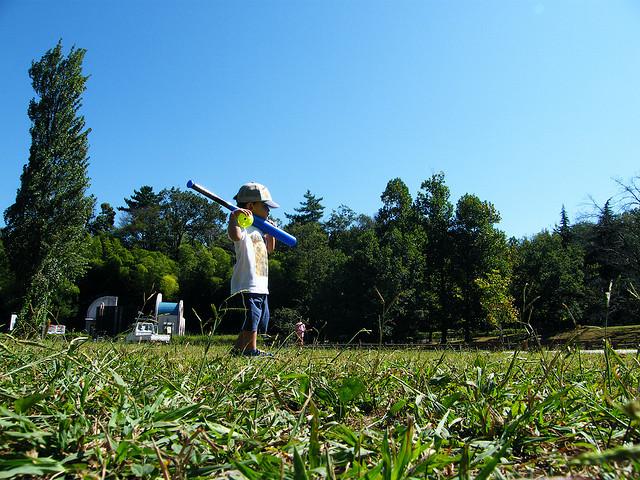Which game is the boy playing?
Be succinct. Baseball. Is this taking place on a regular field?
Quick response, please. Yes. Is this grassy?
Answer briefly. Yes. Did he hit the ball?
Write a very short answer. No. What type of scene is this?
Quick response, please. Park. What kind of trees are there?
Write a very short answer. Pine. What is the boy standing on?
Be succinct. Grass. What is he throwing?
Short answer required. Ball. 